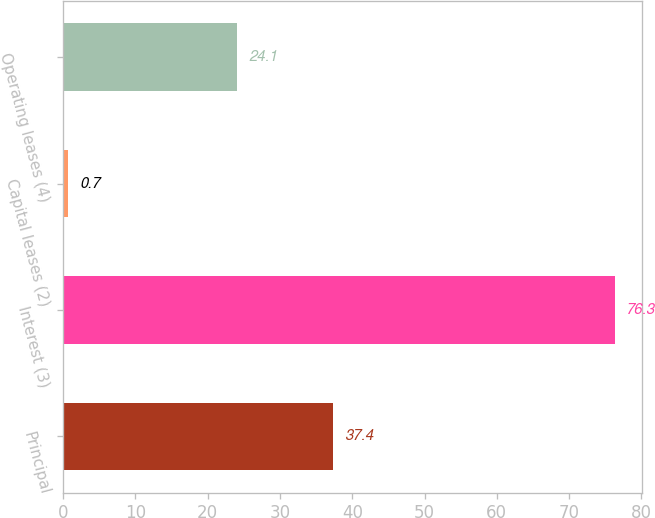Convert chart. <chart><loc_0><loc_0><loc_500><loc_500><bar_chart><fcel>Principal<fcel>Interest (3)<fcel>Capital leases (2)<fcel>Operating leases (4)<nl><fcel>37.4<fcel>76.3<fcel>0.7<fcel>24.1<nl></chart> 